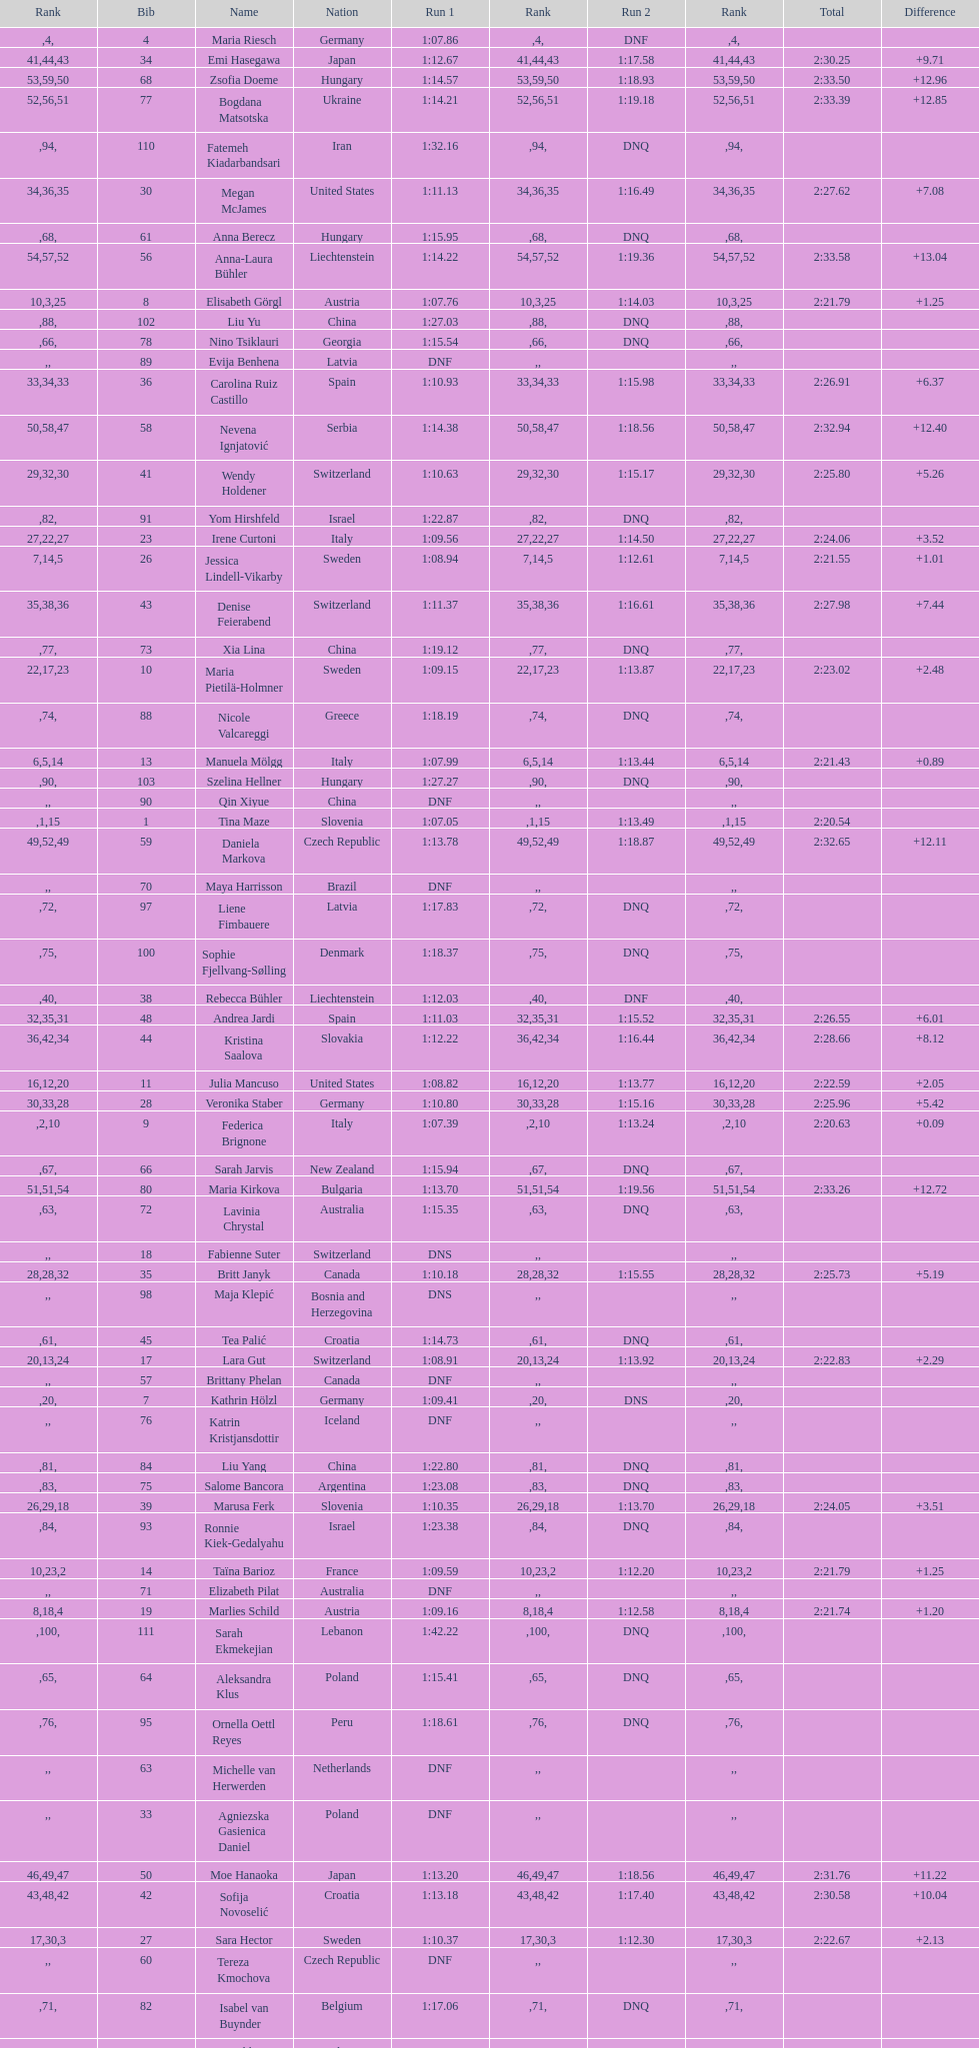Who finished next after federica brignone? Tessa Worley. 